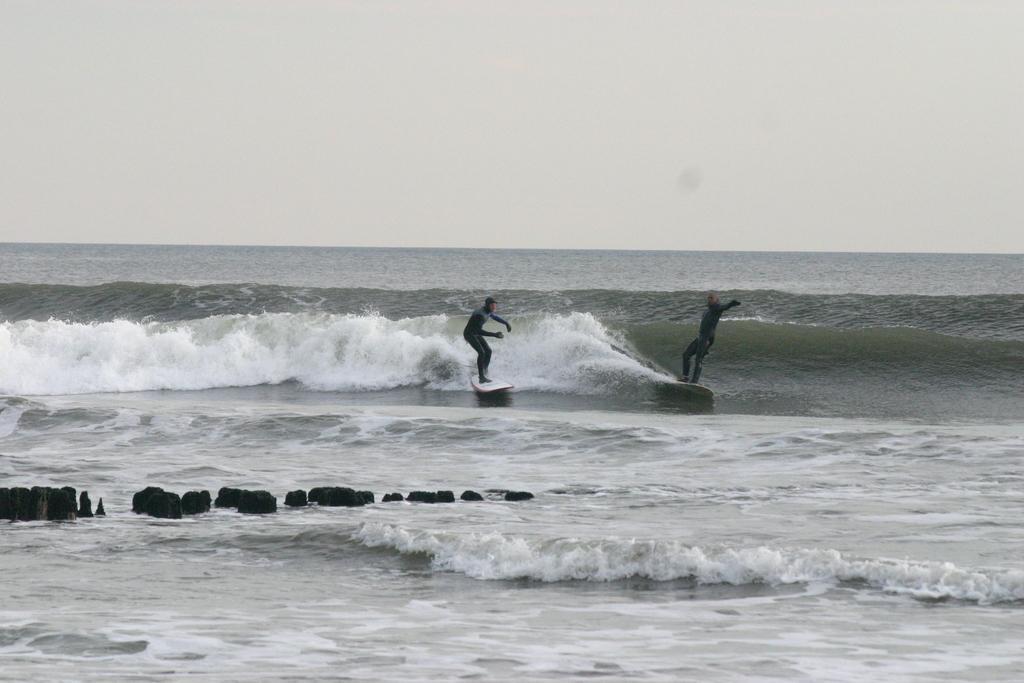Please provide a concise description of this image. In this picture we can see two people on the surfboards. We can see a few objects and waves are visible in the water. There is the sky visible on top of the picture. 